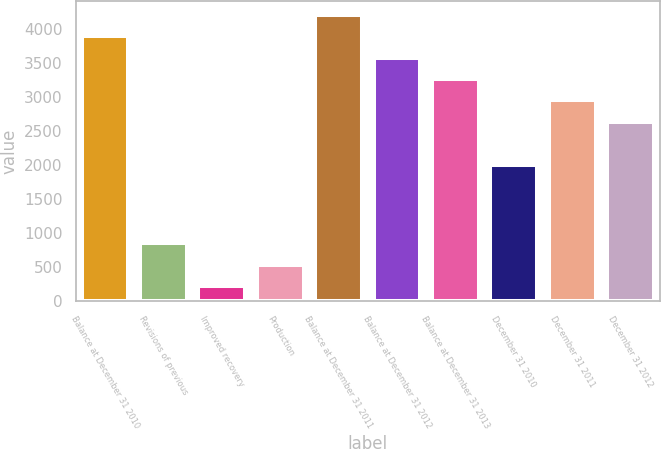<chart> <loc_0><loc_0><loc_500><loc_500><bar_chart><fcel>Balance at December 31 2010<fcel>Revisions of previous<fcel>Improved recovery<fcel>Production<fcel>Balance at December 31 2011<fcel>Balance at December 31 2012<fcel>Balance at December 31 2013<fcel>December 31 2010<fcel>December 31 2011<fcel>December 31 2012<nl><fcel>3892.8<fcel>850.6<fcel>222<fcel>536.3<fcel>4207.1<fcel>3578.5<fcel>3264.2<fcel>2007<fcel>2949.9<fcel>2635.6<nl></chart> 